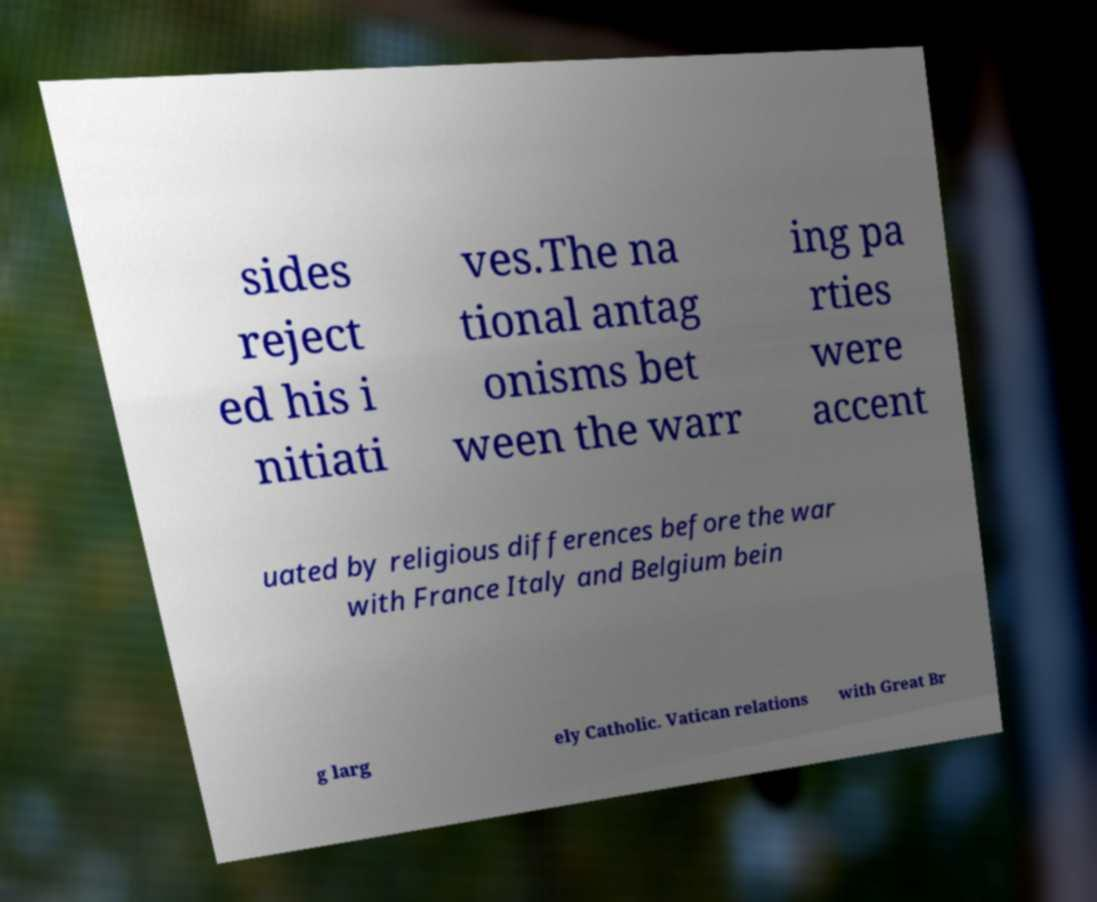Can you read and provide the text displayed in the image?This photo seems to have some interesting text. Can you extract and type it out for me? sides reject ed his i nitiati ves.The na tional antag onisms bet ween the warr ing pa rties were accent uated by religious differences before the war with France Italy and Belgium bein g larg ely Catholic. Vatican relations with Great Br 